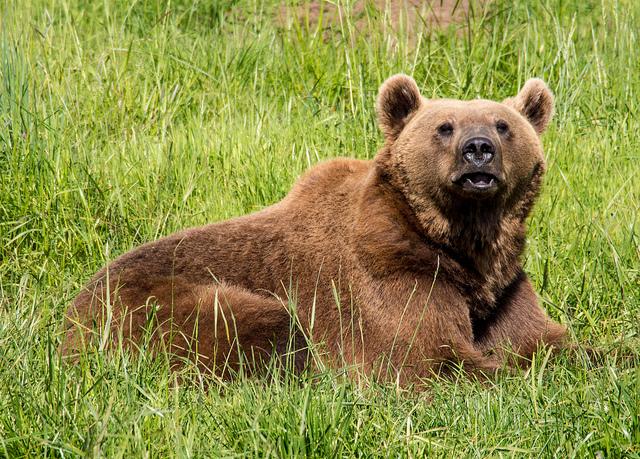How many ears on the bear?
Answer briefly. 2. Is the bear vocalizing?
Be succinct. Yes. Where is this bear native to?
Concise answer only. North america. 